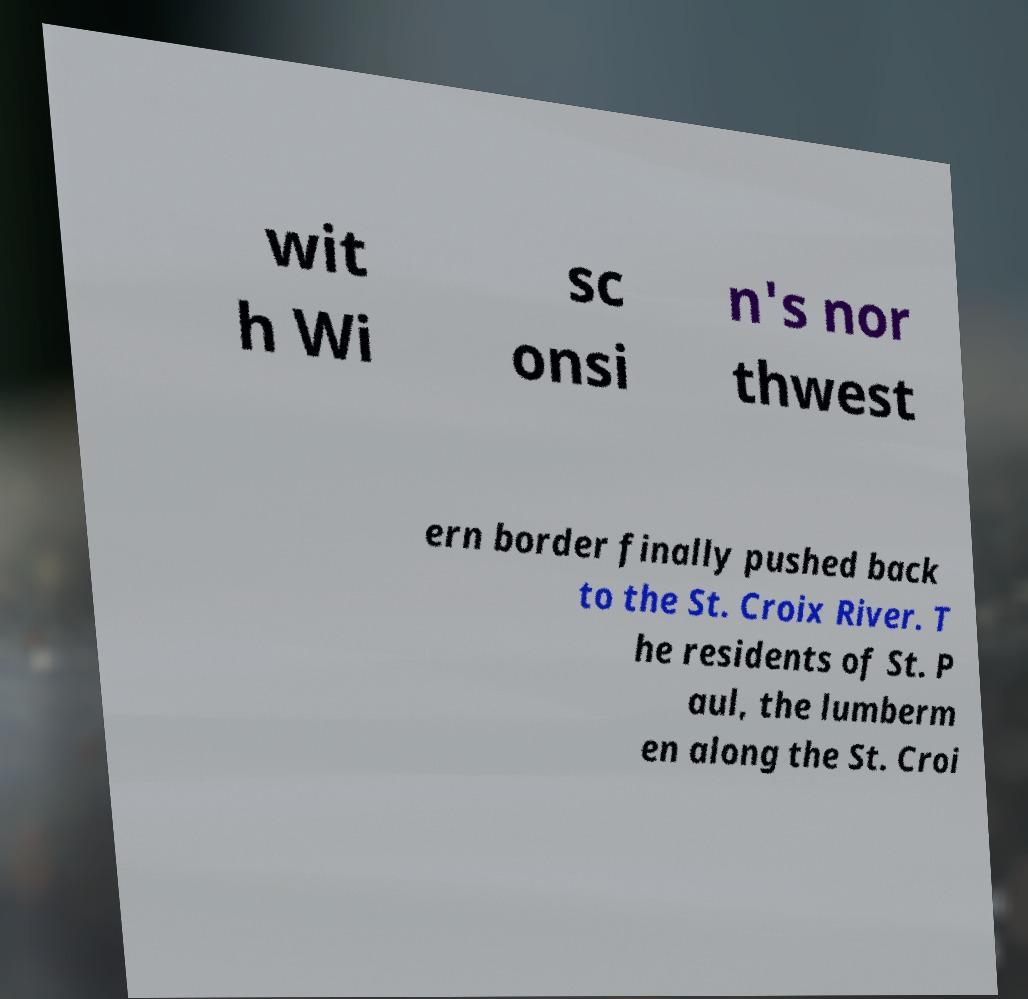Can you read and provide the text displayed in the image?This photo seems to have some interesting text. Can you extract and type it out for me? wit h Wi sc onsi n's nor thwest ern border finally pushed back to the St. Croix River. T he residents of St. P aul, the lumberm en along the St. Croi 